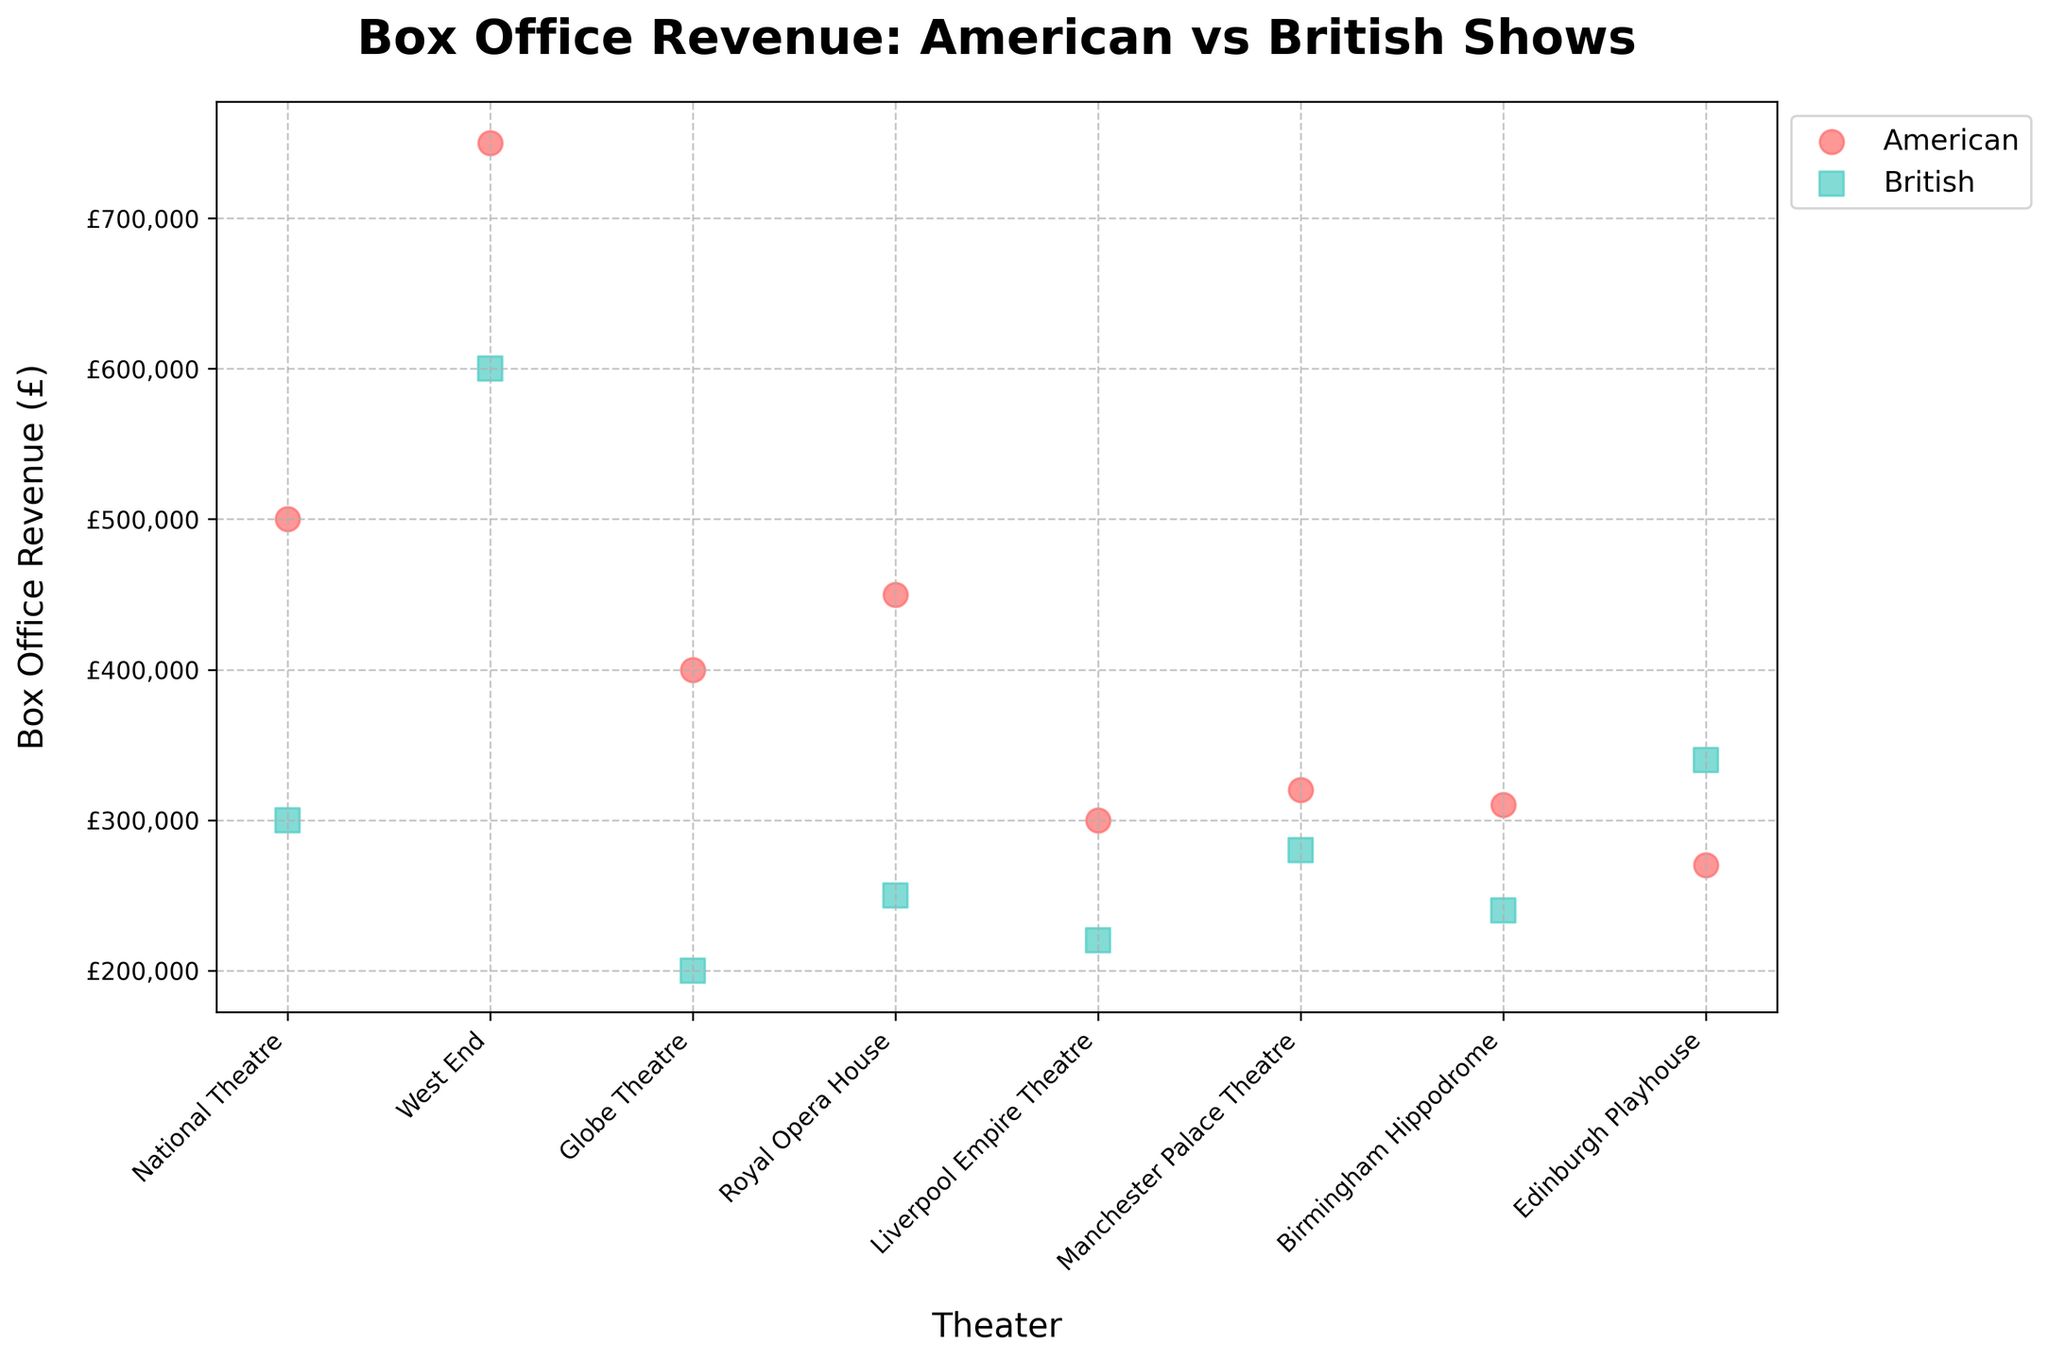How many theaters have shown both American and British productions? There are 7 theaters listed in the data. To determine how many have shown both American and British productions, we check each theater's entries. The National Theatre, West End, Globe Theatre, Royal Opera House, Liverpool Empire Theatre, Manchester Palace Theatre, and Edinburgh Playhouse have both types.
Answer: 7 What is the average box office revenue for American productions? To find this, sum the box office revenue for all American productions and divide by the number of American productions: (500000 + 750000 + 400000 + 450000 + 300000 + 320000 + 310000 + 270000) / 8. The total is 3300000, so the average is 3300000 / 8.
Answer: £412,500 Which theater has the highest box office revenue for a single production, and is it British or American? By examining the scatter plot, the highest box office revenue is 750000 for The Lion King at West End. This show is categorized as American.
Answer: West End, American Which type of show generally has higher box office revenues, American or British? To determine this, compare the overall distribution of revenues for both types. Notice that American shows have several high-revenue points (e.g., 750000, 500000), whereas British shows, though also successful, generally have lower revenue points.
Answer: American What's the combined box office revenue for British shows held at the Globe Theatre and National Theatre? Add the revenue for War Horse (300000) and Macbeth (200000) from the Globe Theatre: 300000 + 200000. This gives a combined revenue.
Answer: £500,000 How does the box office revenue for The Book of Mormon compare to that of Phantom of the Opera at the Royal Opera House? The Book of Mormon has a revenue of 450000, whereas Phantom of the Opera has 250000. Comparing the two, The Book of Mormon has a higher revenue by the difference: 450000 - 250000.
Answer: £200,000 higher Which production has the lowest box office revenue and at which theater is it hosted? By checking the scatter plot, the lowest revenue point is 200000 for Macbeth at the Globe Theatre.
Answer: Macbeth, Globe Theatre What is the total number of American and British productions shown? By counting the scatter plot points, count the number of American and British productions separately. There are 8 American and 8 British productions in total.
Answer: 8 American, 8 British Are there any theaters where British productions outperform American ones in terms of box office revenue? To answer this, compare the revenues for American and British productions within each theater: 
 - National Theatre: American (500000) vs. British (300000) -> American wins.
 - West End: American (750000) vs. British (600000) -> American wins.
 - Globe Theatre: American (400000) vs. British (200000) -> American wins.
 - Royal Opera House: American (450000) vs. British (250000) -> American wins.
 - Liverpool Empire Theatre: American (300000) vs. British (220000) -> American wins.
 - Manchester Palace Theatre: American (320000) vs. British (280000) -> American wins.
 - Birmingham Hippodrome: American (310000) vs. British (240000) -> American wins.
 - Edinburgh Playhouse: American (270000) vs. British (340000) -> British wins.
 
 Only the Edinburgh Playhouse is where the British production outperforms.
Answer: Edinburgh Playhouse 